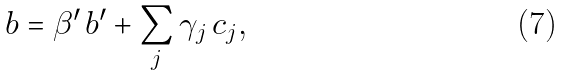<formula> <loc_0><loc_0><loc_500><loc_500>b = \beta ^ { \prime } \, b ^ { \prime } + \sum _ { j } \gamma _ { j } \, c _ { j } ,</formula> 